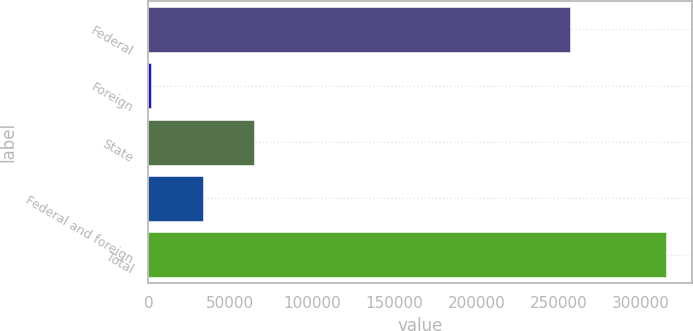<chart> <loc_0><loc_0><loc_500><loc_500><bar_chart><fcel>Federal<fcel>Foreign<fcel>State<fcel>Federal and foreign<fcel>Total<nl><fcel>256545<fcel>1655<fcel>64385.8<fcel>33020.4<fcel>315309<nl></chart> 